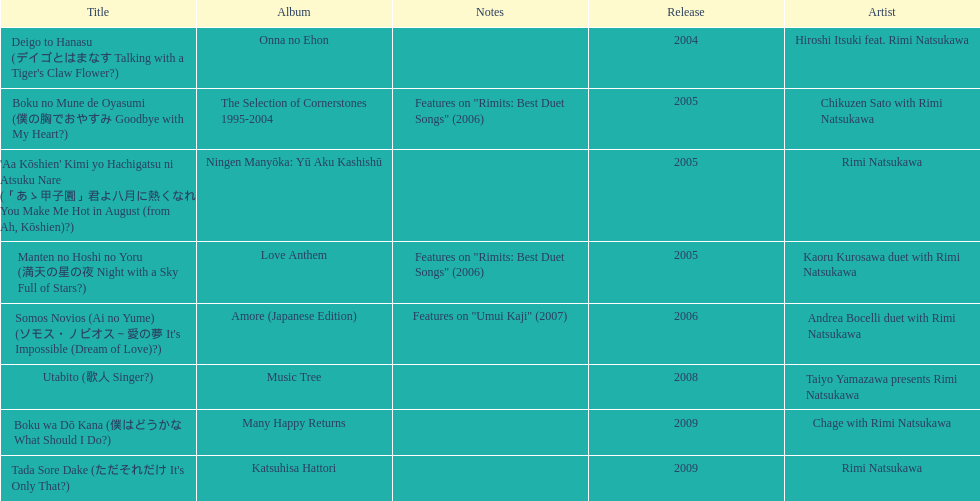Which title has the same notes as night with a sky full of stars? Boku no Mune de Oyasumi (僕の胸でおやすみ Goodbye with My Heart?). 